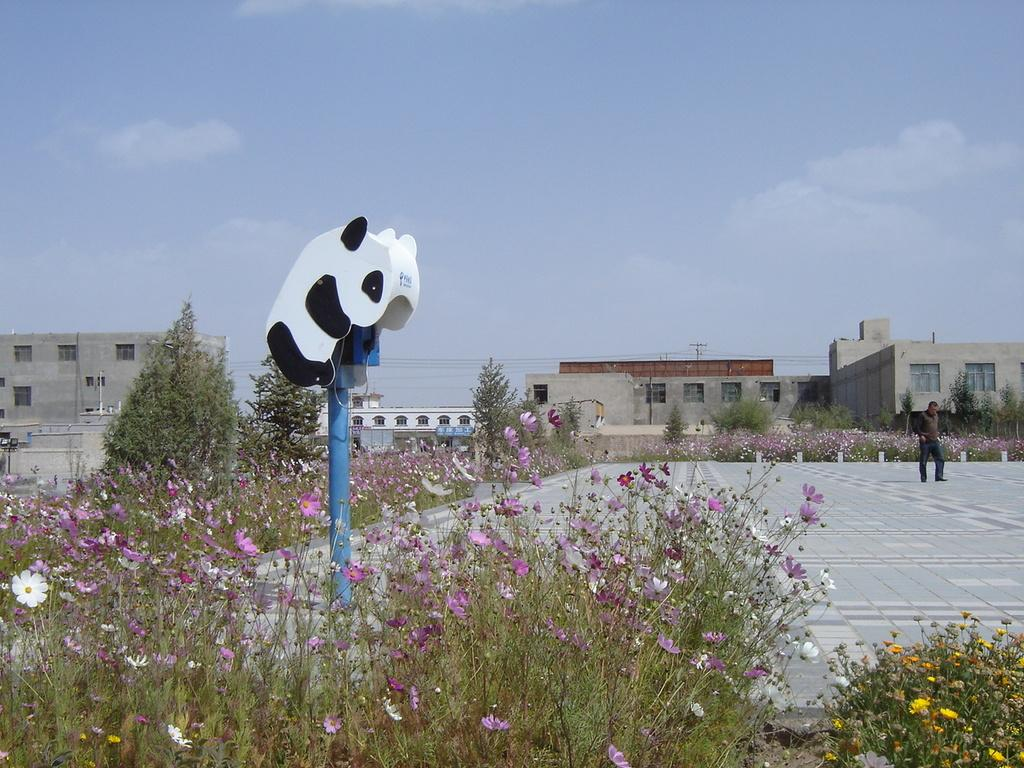What type of plants can be seen in the image? There are flowers in the image. What structure is present in the image? There is a pole in the image. What type of buildings are visible in the image? There are buildings with windows in the image. What else can be seen in the image besides the flowers, pole, and buildings? There are wires in the image. What is the man in the image doing? The man is walking on the ground in the image. What can be seen in the background of the image? The sky with clouds is visible in the background of the image. What type of slope can be seen in the image? There is no slope present in the image. How many houses are visible in the image? The image does not show any houses; it features buildings with windows. 